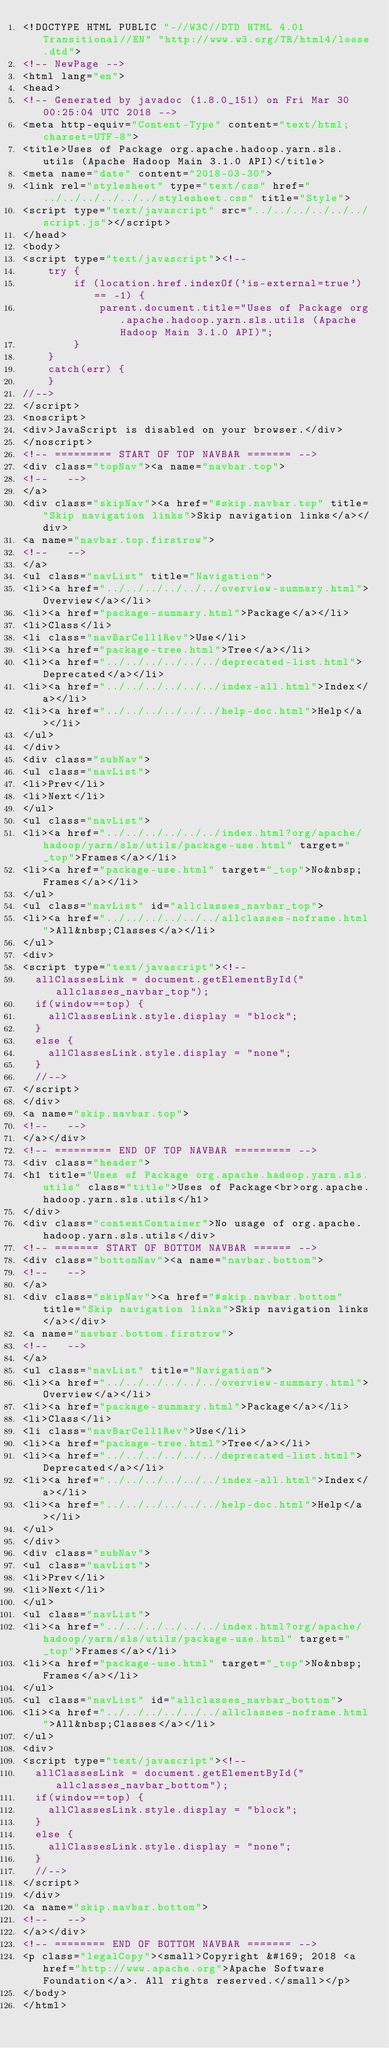Convert code to text. <code><loc_0><loc_0><loc_500><loc_500><_HTML_><!DOCTYPE HTML PUBLIC "-//W3C//DTD HTML 4.01 Transitional//EN" "http://www.w3.org/TR/html4/loose.dtd">
<!-- NewPage -->
<html lang="en">
<head>
<!-- Generated by javadoc (1.8.0_151) on Fri Mar 30 00:25:04 UTC 2018 -->
<meta http-equiv="Content-Type" content="text/html; charset=UTF-8">
<title>Uses of Package org.apache.hadoop.yarn.sls.utils (Apache Hadoop Main 3.1.0 API)</title>
<meta name="date" content="2018-03-30">
<link rel="stylesheet" type="text/css" href="../../../../../../stylesheet.css" title="Style">
<script type="text/javascript" src="../../../../../../script.js"></script>
</head>
<body>
<script type="text/javascript"><!--
    try {
        if (location.href.indexOf('is-external=true') == -1) {
            parent.document.title="Uses of Package org.apache.hadoop.yarn.sls.utils (Apache Hadoop Main 3.1.0 API)";
        }
    }
    catch(err) {
    }
//-->
</script>
<noscript>
<div>JavaScript is disabled on your browser.</div>
</noscript>
<!-- ========= START OF TOP NAVBAR ======= -->
<div class="topNav"><a name="navbar.top">
<!--   -->
</a>
<div class="skipNav"><a href="#skip.navbar.top" title="Skip navigation links">Skip navigation links</a></div>
<a name="navbar.top.firstrow">
<!--   -->
</a>
<ul class="navList" title="Navigation">
<li><a href="../../../../../../overview-summary.html">Overview</a></li>
<li><a href="package-summary.html">Package</a></li>
<li>Class</li>
<li class="navBarCell1Rev">Use</li>
<li><a href="package-tree.html">Tree</a></li>
<li><a href="../../../../../../deprecated-list.html">Deprecated</a></li>
<li><a href="../../../../../../index-all.html">Index</a></li>
<li><a href="../../../../../../help-doc.html">Help</a></li>
</ul>
</div>
<div class="subNav">
<ul class="navList">
<li>Prev</li>
<li>Next</li>
</ul>
<ul class="navList">
<li><a href="../../../../../../index.html?org/apache/hadoop/yarn/sls/utils/package-use.html" target="_top">Frames</a></li>
<li><a href="package-use.html" target="_top">No&nbsp;Frames</a></li>
</ul>
<ul class="navList" id="allclasses_navbar_top">
<li><a href="../../../../../../allclasses-noframe.html">All&nbsp;Classes</a></li>
</ul>
<div>
<script type="text/javascript"><!--
  allClassesLink = document.getElementById("allclasses_navbar_top");
  if(window==top) {
    allClassesLink.style.display = "block";
  }
  else {
    allClassesLink.style.display = "none";
  }
  //-->
</script>
</div>
<a name="skip.navbar.top">
<!--   -->
</a></div>
<!-- ========= END OF TOP NAVBAR ========= -->
<div class="header">
<h1 title="Uses of Package org.apache.hadoop.yarn.sls.utils" class="title">Uses of Package<br>org.apache.hadoop.yarn.sls.utils</h1>
</div>
<div class="contentContainer">No usage of org.apache.hadoop.yarn.sls.utils</div>
<!-- ======= START OF BOTTOM NAVBAR ====== -->
<div class="bottomNav"><a name="navbar.bottom">
<!--   -->
</a>
<div class="skipNav"><a href="#skip.navbar.bottom" title="Skip navigation links">Skip navigation links</a></div>
<a name="navbar.bottom.firstrow">
<!--   -->
</a>
<ul class="navList" title="Navigation">
<li><a href="../../../../../../overview-summary.html">Overview</a></li>
<li><a href="package-summary.html">Package</a></li>
<li>Class</li>
<li class="navBarCell1Rev">Use</li>
<li><a href="package-tree.html">Tree</a></li>
<li><a href="../../../../../../deprecated-list.html">Deprecated</a></li>
<li><a href="../../../../../../index-all.html">Index</a></li>
<li><a href="../../../../../../help-doc.html">Help</a></li>
</ul>
</div>
<div class="subNav">
<ul class="navList">
<li>Prev</li>
<li>Next</li>
</ul>
<ul class="navList">
<li><a href="../../../../../../index.html?org/apache/hadoop/yarn/sls/utils/package-use.html" target="_top">Frames</a></li>
<li><a href="package-use.html" target="_top">No&nbsp;Frames</a></li>
</ul>
<ul class="navList" id="allclasses_navbar_bottom">
<li><a href="../../../../../../allclasses-noframe.html">All&nbsp;Classes</a></li>
</ul>
<div>
<script type="text/javascript"><!--
  allClassesLink = document.getElementById("allclasses_navbar_bottom");
  if(window==top) {
    allClassesLink.style.display = "block";
  }
  else {
    allClassesLink.style.display = "none";
  }
  //-->
</script>
</div>
<a name="skip.navbar.bottom">
<!--   -->
</a></div>
<!-- ======== END OF BOTTOM NAVBAR ======= -->
<p class="legalCopy"><small>Copyright &#169; 2018 <a href="http://www.apache.org">Apache Software Foundation</a>. All rights reserved.</small></p>
</body>
</html>
</code> 